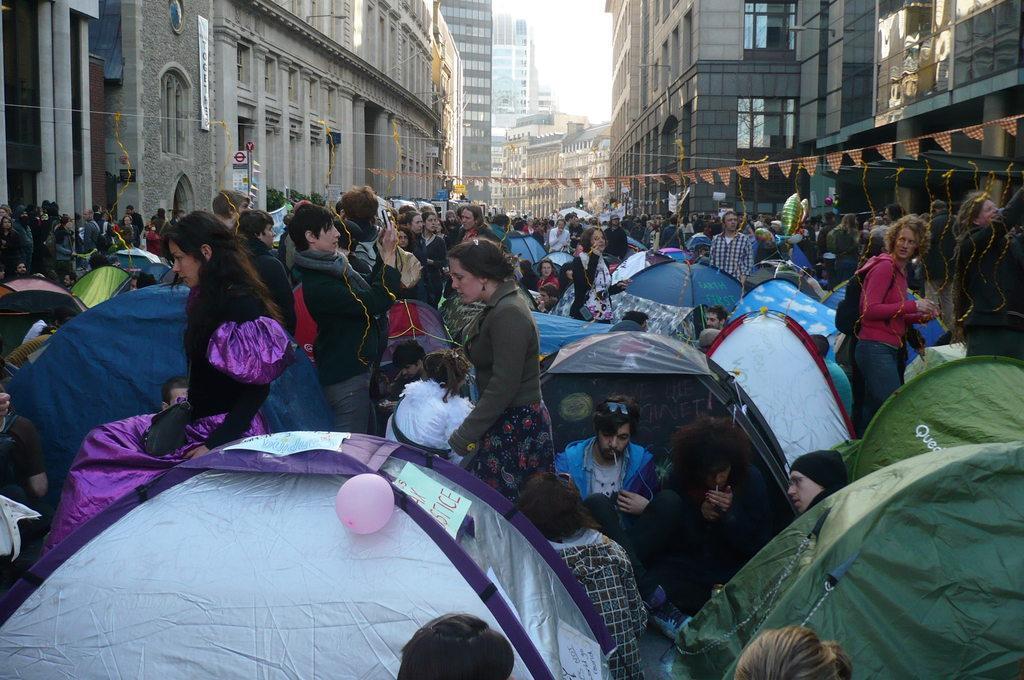How would you summarize this image in a sentence or two? In this image, there are a few people. We can see some tents. We can see some flags. We can see a wire with some object. We can see some banners. There are a few buildings and some lights on them. We can see the sky. 